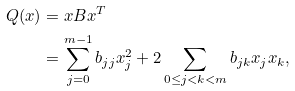Convert formula to latex. <formula><loc_0><loc_0><loc_500><loc_500>Q ( x ) & = x B x ^ { T } \\ & = \sum _ { j = 0 } ^ { m - 1 } b _ { j j } x _ { j } ^ { 2 } + 2 \sum _ { 0 \leq j < k < m } b _ { j k } x _ { j } x _ { k } ,</formula> 